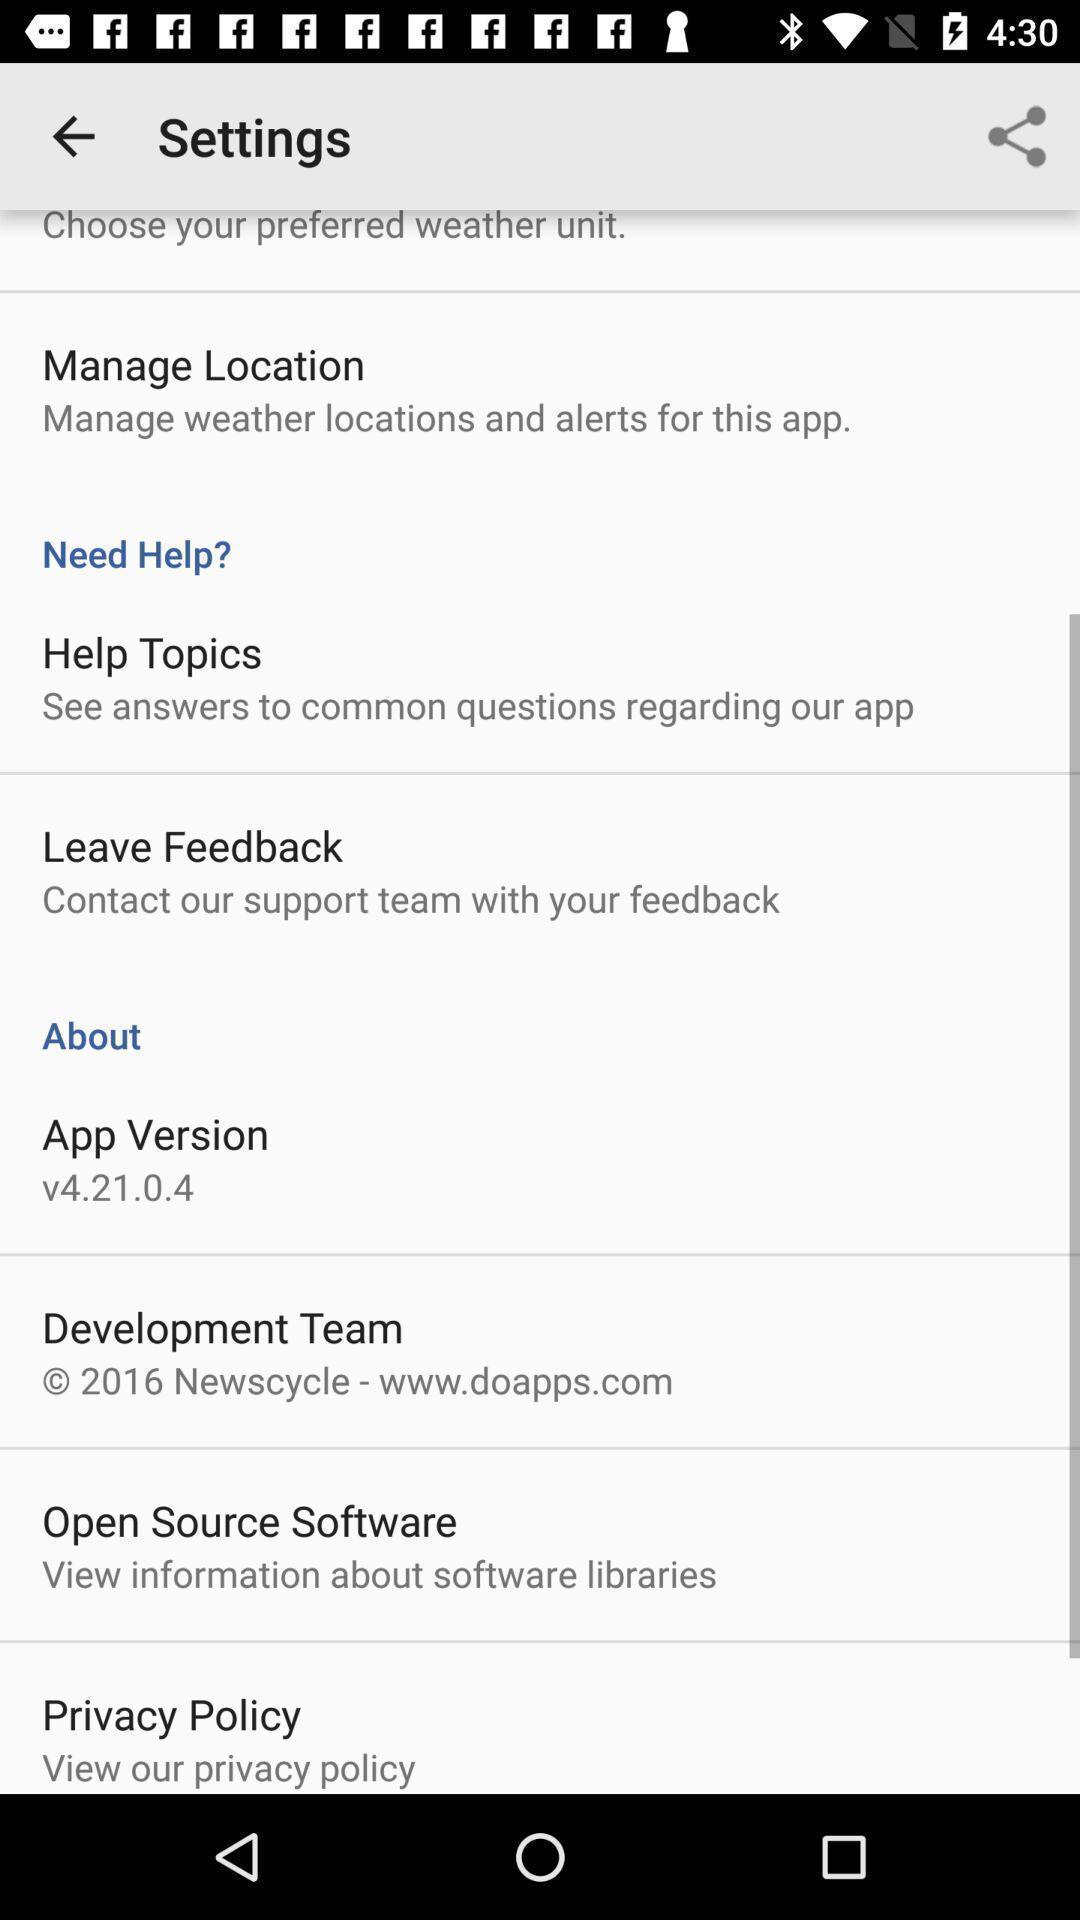What can you discern from this picture? Settings page. 